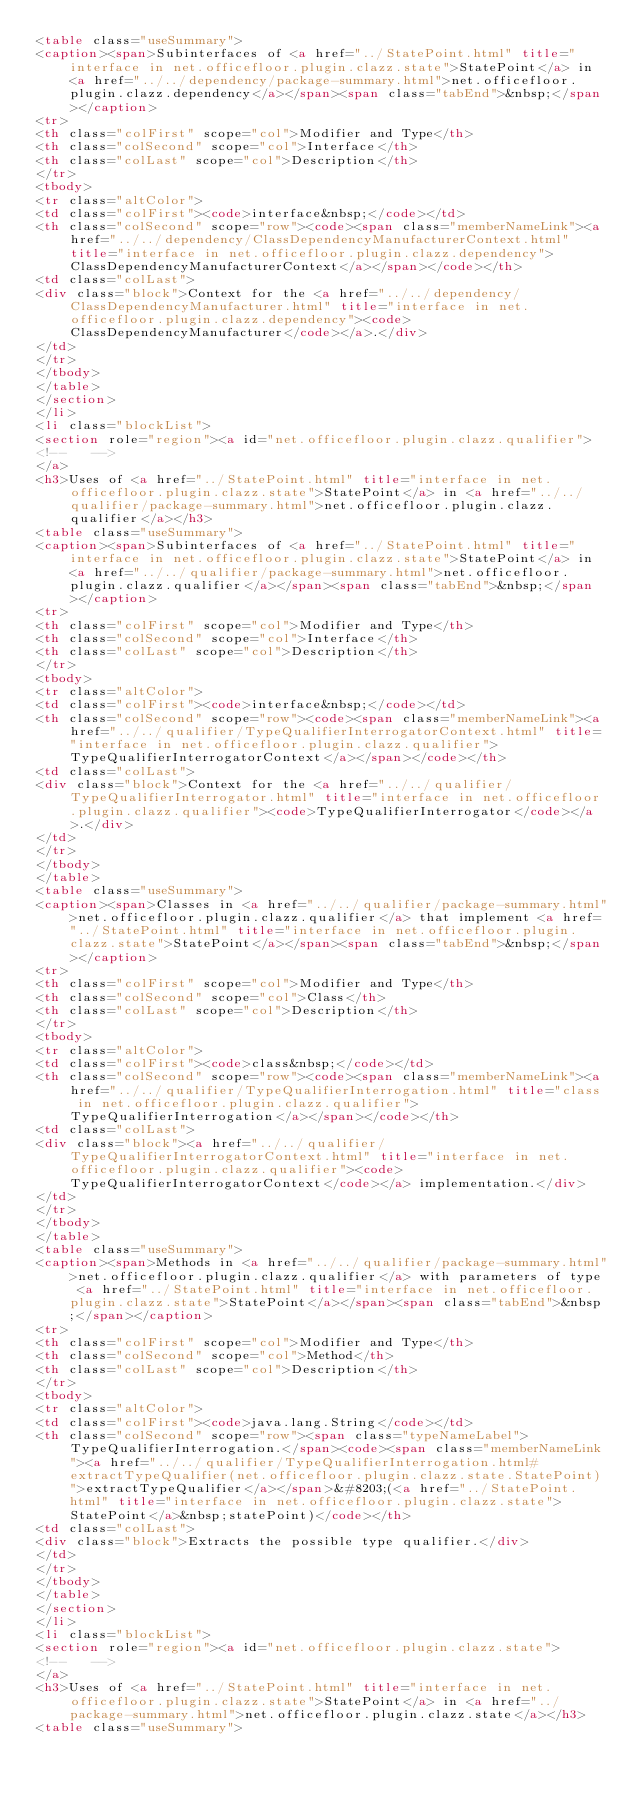Convert code to text. <code><loc_0><loc_0><loc_500><loc_500><_HTML_><table class="useSummary">
<caption><span>Subinterfaces of <a href="../StatePoint.html" title="interface in net.officefloor.plugin.clazz.state">StatePoint</a> in <a href="../../dependency/package-summary.html">net.officefloor.plugin.clazz.dependency</a></span><span class="tabEnd">&nbsp;</span></caption>
<tr>
<th class="colFirst" scope="col">Modifier and Type</th>
<th class="colSecond" scope="col">Interface</th>
<th class="colLast" scope="col">Description</th>
</tr>
<tbody>
<tr class="altColor">
<td class="colFirst"><code>interface&nbsp;</code></td>
<th class="colSecond" scope="row"><code><span class="memberNameLink"><a href="../../dependency/ClassDependencyManufacturerContext.html" title="interface in net.officefloor.plugin.clazz.dependency">ClassDependencyManufacturerContext</a></span></code></th>
<td class="colLast">
<div class="block">Context for the <a href="../../dependency/ClassDependencyManufacturer.html" title="interface in net.officefloor.plugin.clazz.dependency"><code>ClassDependencyManufacturer</code></a>.</div>
</td>
</tr>
</tbody>
</table>
</section>
</li>
<li class="blockList">
<section role="region"><a id="net.officefloor.plugin.clazz.qualifier">
<!--   -->
</a>
<h3>Uses of <a href="../StatePoint.html" title="interface in net.officefloor.plugin.clazz.state">StatePoint</a> in <a href="../../qualifier/package-summary.html">net.officefloor.plugin.clazz.qualifier</a></h3>
<table class="useSummary">
<caption><span>Subinterfaces of <a href="../StatePoint.html" title="interface in net.officefloor.plugin.clazz.state">StatePoint</a> in <a href="../../qualifier/package-summary.html">net.officefloor.plugin.clazz.qualifier</a></span><span class="tabEnd">&nbsp;</span></caption>
<tr>
<th class="colFirst" scope="col">Modifier and Type</th>
<th class="colSecond" scope="col">Interface</th>
<th class="colLast" scope="col">Description</th>
</tr>
<tbody>
<tr class="altColor">
<td class="colFirst"><code>interface&nbsp;</code></td>
<th class="colSecond" scope="row"><code><span class="memberNameLink"><a href="../../qualifier/TypeQualifierInterrogatorContext.html" title="interface in net.officefloor.plugin.clazz.qualifier">TypeQualifierInterrogatorContext</a></span></code></th>
<td class="colLast">
<div class="block">Context for the <a href="../../qualifier/TypeQualifierInterrogator.html" title="interface in net.officefloor.plugin.clazz.qualifier"><code>TypeQualifierInterrogator</code></a>.</div>
</td>
</tr>
</tbody>
</table>
<table class="useSummary">
<caption><span>Classes in <a href="../../qualifier/package-summary.html">net.officefloor.plugin.clazz.qualifier</a> that implement <a href="../StatePoint.html" title="interface in net.officefloor.plugin.clazz.state">StatePoint</a></span><span class="tabEnd">&nbsp;</span></caption>
<tr>
<th class="colFirst" scope="col">Modifier and Type</th>
<th class="colSecond" scope="col">Class</th>
<th class="colLast" scope="col">Description</th>
</tr>
<tbody>
<tr class="altColor">
<td class="colFirst"><code>class&nbsp;</code></td>
<th class="colSecond" scope="row"><code><span class="memberNameLink"><a href="../../qualifier/TypeQualifierInterrogation.html" title="class in net.officefloor.plugin.clazz.qualifier">TypeQualifierInterrogation</a></span></code></th>
<td class="colLast">
<div class="block"><a href="../../qualifier/TypeQualifierInterrogatorContext.html" title="interface in net.officefloor.plugin.clazz.qualifier"><code>TypeQualifierInterrogatorContext</code></a> implementation.</div>
</td>
</tr>
</tbody>
</table>
<table class="useSummary">
<caption><span>Methods in <a href="../../qualifier/package-summary.html">net.officefloor.plugin.clazz.qualifier</a> with parameters of type <a href="../StatePoint.html" title="interface in net.officefloor.plugin.clazz.state">StatePoint</a></span><span class="tabEnd">&nbsp;</span></caption>
<tr>
<th class="colFirst" scope="col">Modifier and Type</th>
<th class="colSecond" scope="col">Method</th>
<th class="colLast" scope="col">Description</th>
</tr>
<tbody>
<tr class="altColor">
<td class="colFirst"><code>java.lang.String</code></td>
<th class="colSecond" scope="row"><span class="typeNameLabel">TypeQualifierInterrogation.</span><code><span class="memberNameLink"><a href="../../qualifier/TypeQualifierInterrogation.html#extractTypeQualifier(net.officefloor.plugin.clazz.state.StatePoint)">extractTypeQualifier</a></span>&#8203;(<a href="../StatePoint.html" title="interface in net.officefloor.plugin.clazz.state">StatePoint</a>&nbsp;statePoint)</code></th>
<td class="colLast">
<div class="block">Extracts the possible type qualifier.</div>
</td>
</tr>
</tbody>
</table>
</section>
</li>
<li class="blockList">
<section role="region"><a id="net.officefloor.plugin.clazz.state">
<!--   -->
</a>
<h3>Uses of <a href="../StatePoint.html" title="interface in net.officefloor.plugin.clazz.state">StatePoint</a> in <a href="../package-summary.html">net.officefloor.plugin.clazz.state</a></h3>
<table class="useSummary"></code> 